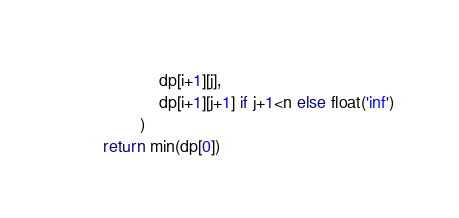Convert code to text. <code><loc_0><loc_0><loc_500><loc_500><_Python_>                    dp[i+1][j],
                    dp[i+1][j+1] if j+1<n else float('inf')
                )
        return min(dp[0])</code> 